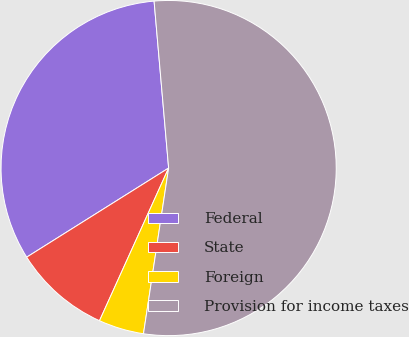<chart> <loc_0><loc_0><loc_500><loc_500><pie_chart><fcel>Federal<fcel>State<fcel>Foreign<fcel>Provision for income taxes<nl><fcel>32.54%<fcel>9.31%<fcel>4.37%<fcel>53.78%<nl></chart> 